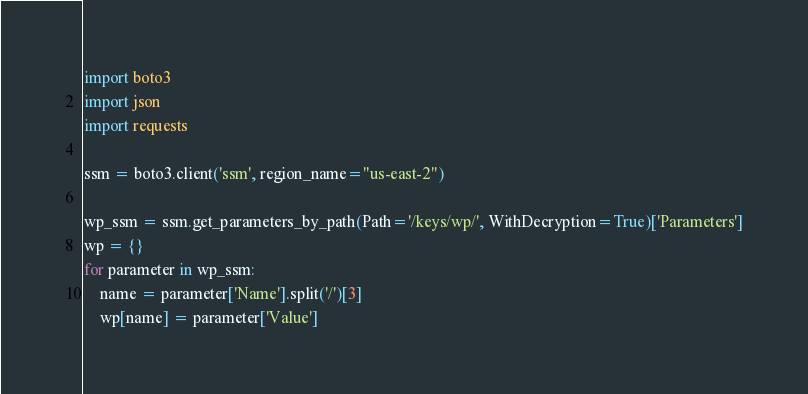Convert code to text. <code><loc_0><loc_0><loc_500><loc_500><_Python_>import boto3
import json
import requests

ssm = boto3.client('ssm', region_name="us-east-2")

wp_ssm = ssm.get_parameters_by_path(Path='/keys/wp/', WithDecryption=True)['Parameters']
wp = {}
for parameter in wp_ssm:
    name = parameter['Name'].split('/')[3]
    wp[name] = parameter['Value']</code> 